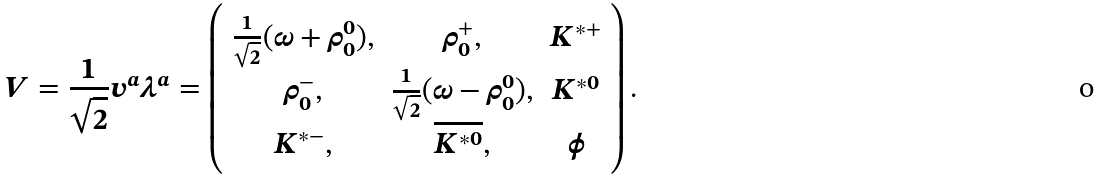Convert formula to latex. <formula><loc_0><loc_0><loc_500><loc_500>V = \frac { 1 } { \sqrt { 2 } } v ^ { a } \lambda ^ { a } = \left ( \begin{array} { c c c } \frac { 1 } { \sqrt { 2 } } ( \omega + \rho _ { 0 } ^ { 0 } ) , & \rho _ { 0 } ^ { + } , & K ^ { \ast + } \\ \rho _ { 0 } ^ { - } , & \frac { 1 } { \sqrt { 2 } } ( \omega - \rho _ { 0 } ^ { 0 } ) , & K ^ { \ast 0 } \\ K ^ { \ast - } , & \overline { K ^ { \ast 0 } } , & \phi \\ \end{array} \right ) .</formula> 